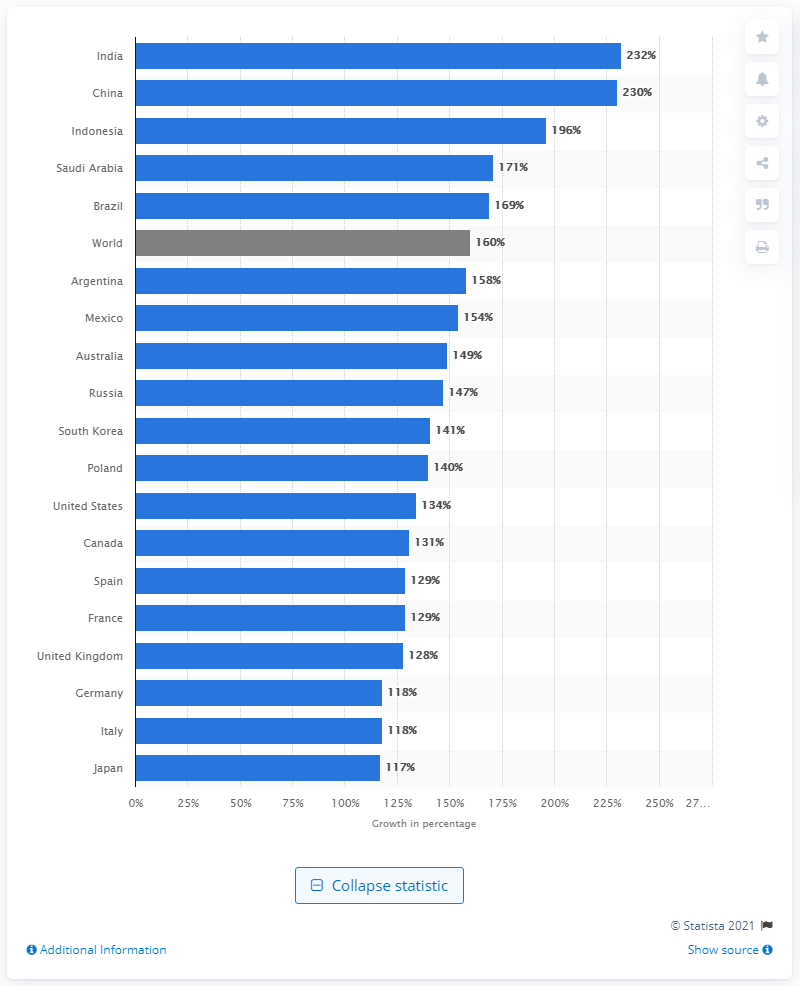Outline some significant characteristics in this image. According to the forecast, the pharmaceutical sector is expected to grow by 160% between 2017 and 2030. The forecast for the biggest growth in India is expected to be 232%. 